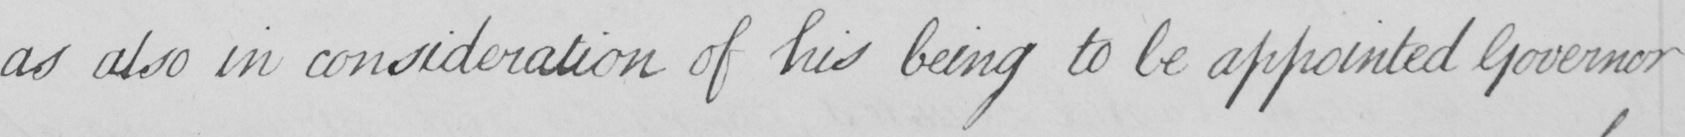Please provide the text content of this handwritten line. as also in consideration of his being to be appointed Governor 